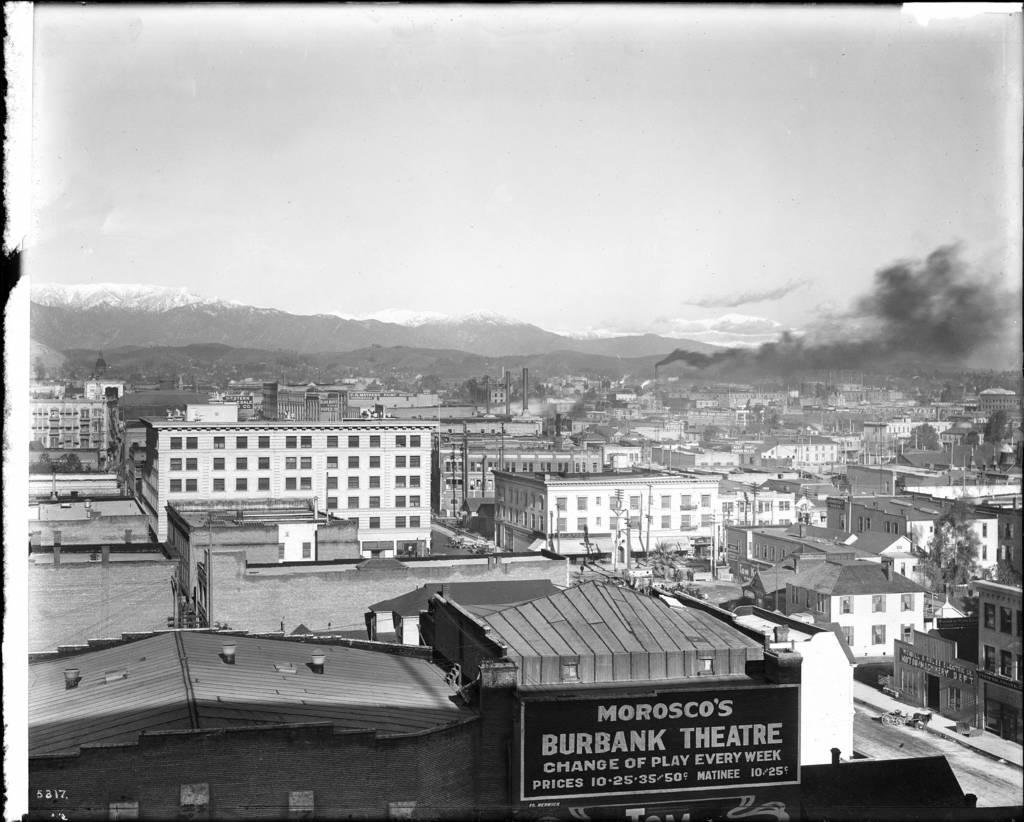What theatre is talked about on the side of the building?
Keep it short and to the point. Morosco's burbank theatre. How often does the theater offer a change of play?
Provide a short and direct response. Every week. 